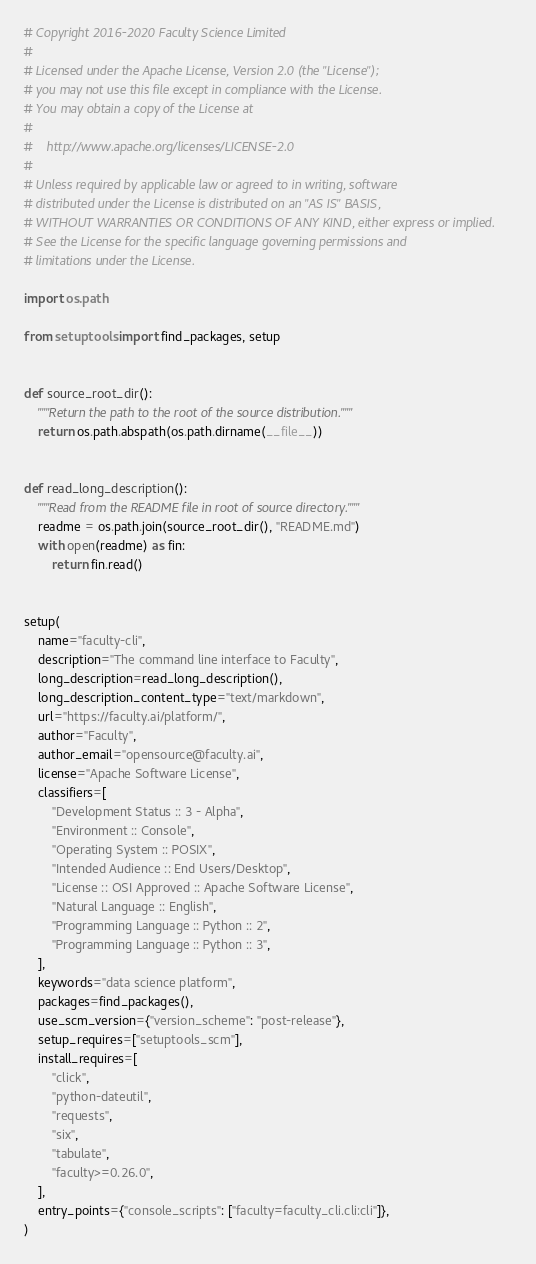<code> <loc_0><loc_0><loc_500><loc_500><_Python_># Copyright 2016-2020 Faculty Science Limited
#
# Licensed under the Apache License, Version 2.0 (the "License");
# you may not use this file except in compliance with the License.
# You may obtain a copy of the License at
#
#    http://www.apache.org/licenses/LICENSE-2.0
#
# Unless required by applicable law or agreed to in writing, software
# distributed under the License is distributed on an "AS IS" BASIS,
# WITHOUT WARRANTIES OR CONDITIONS OF ANY KIND, either express or implied.
# See the License for the specific language governing permissions and
# limitations under the License.

import os.path

from setuptools import find_packages, setup


def source_root_dir():
    """Return the path to the root of the source distribution."""
    return os.path.abspath(os.path.dirname(__file__))


def read_long_description():
    """Read from the README file in root of source directory."""
    readme = os.path.join(source_root_dir(), "README.md")
    with open(readme) as fin:
        return fin.read()


setup(
    name="faculty-cli",
    description="The command line interface to Faculty",
    long_description=read_long_description(),
    long_description_content_type="text/markdown",
    url="https://faculty.ai/platform/",
    author="Faculty",
    author_email="opensource@faculty.ai",
    license="Apache Software License",
    classifiers=[
        "Development Status :: 3 - Alpha",
        "Environment :: Console",
        "Operating System :: POSIX",
        "Intended Audience :: End Users/Desktop",
        "License :: OSI Approved :: Apache Software License",
        "Natural Language :: English",
        "Programming Language :: Python :: 2",
        "Programming Language :: Python :: 3",
    ],
    keywords="data science platform",
    packages=find_packages(),
    use_scm_version={"version_scheme": "post-release"},
    setup_requires=["setuptools_scm"],
    install_requires=[
        "click",
        "python-dateutil",
        "requests",
        "six",
        "tabulate",
        "faculty>=0.26.0",
    ],
    entry_points={"console_scripts": ["faculty=faculty_cli.cli:cli"]},
)
</code> 